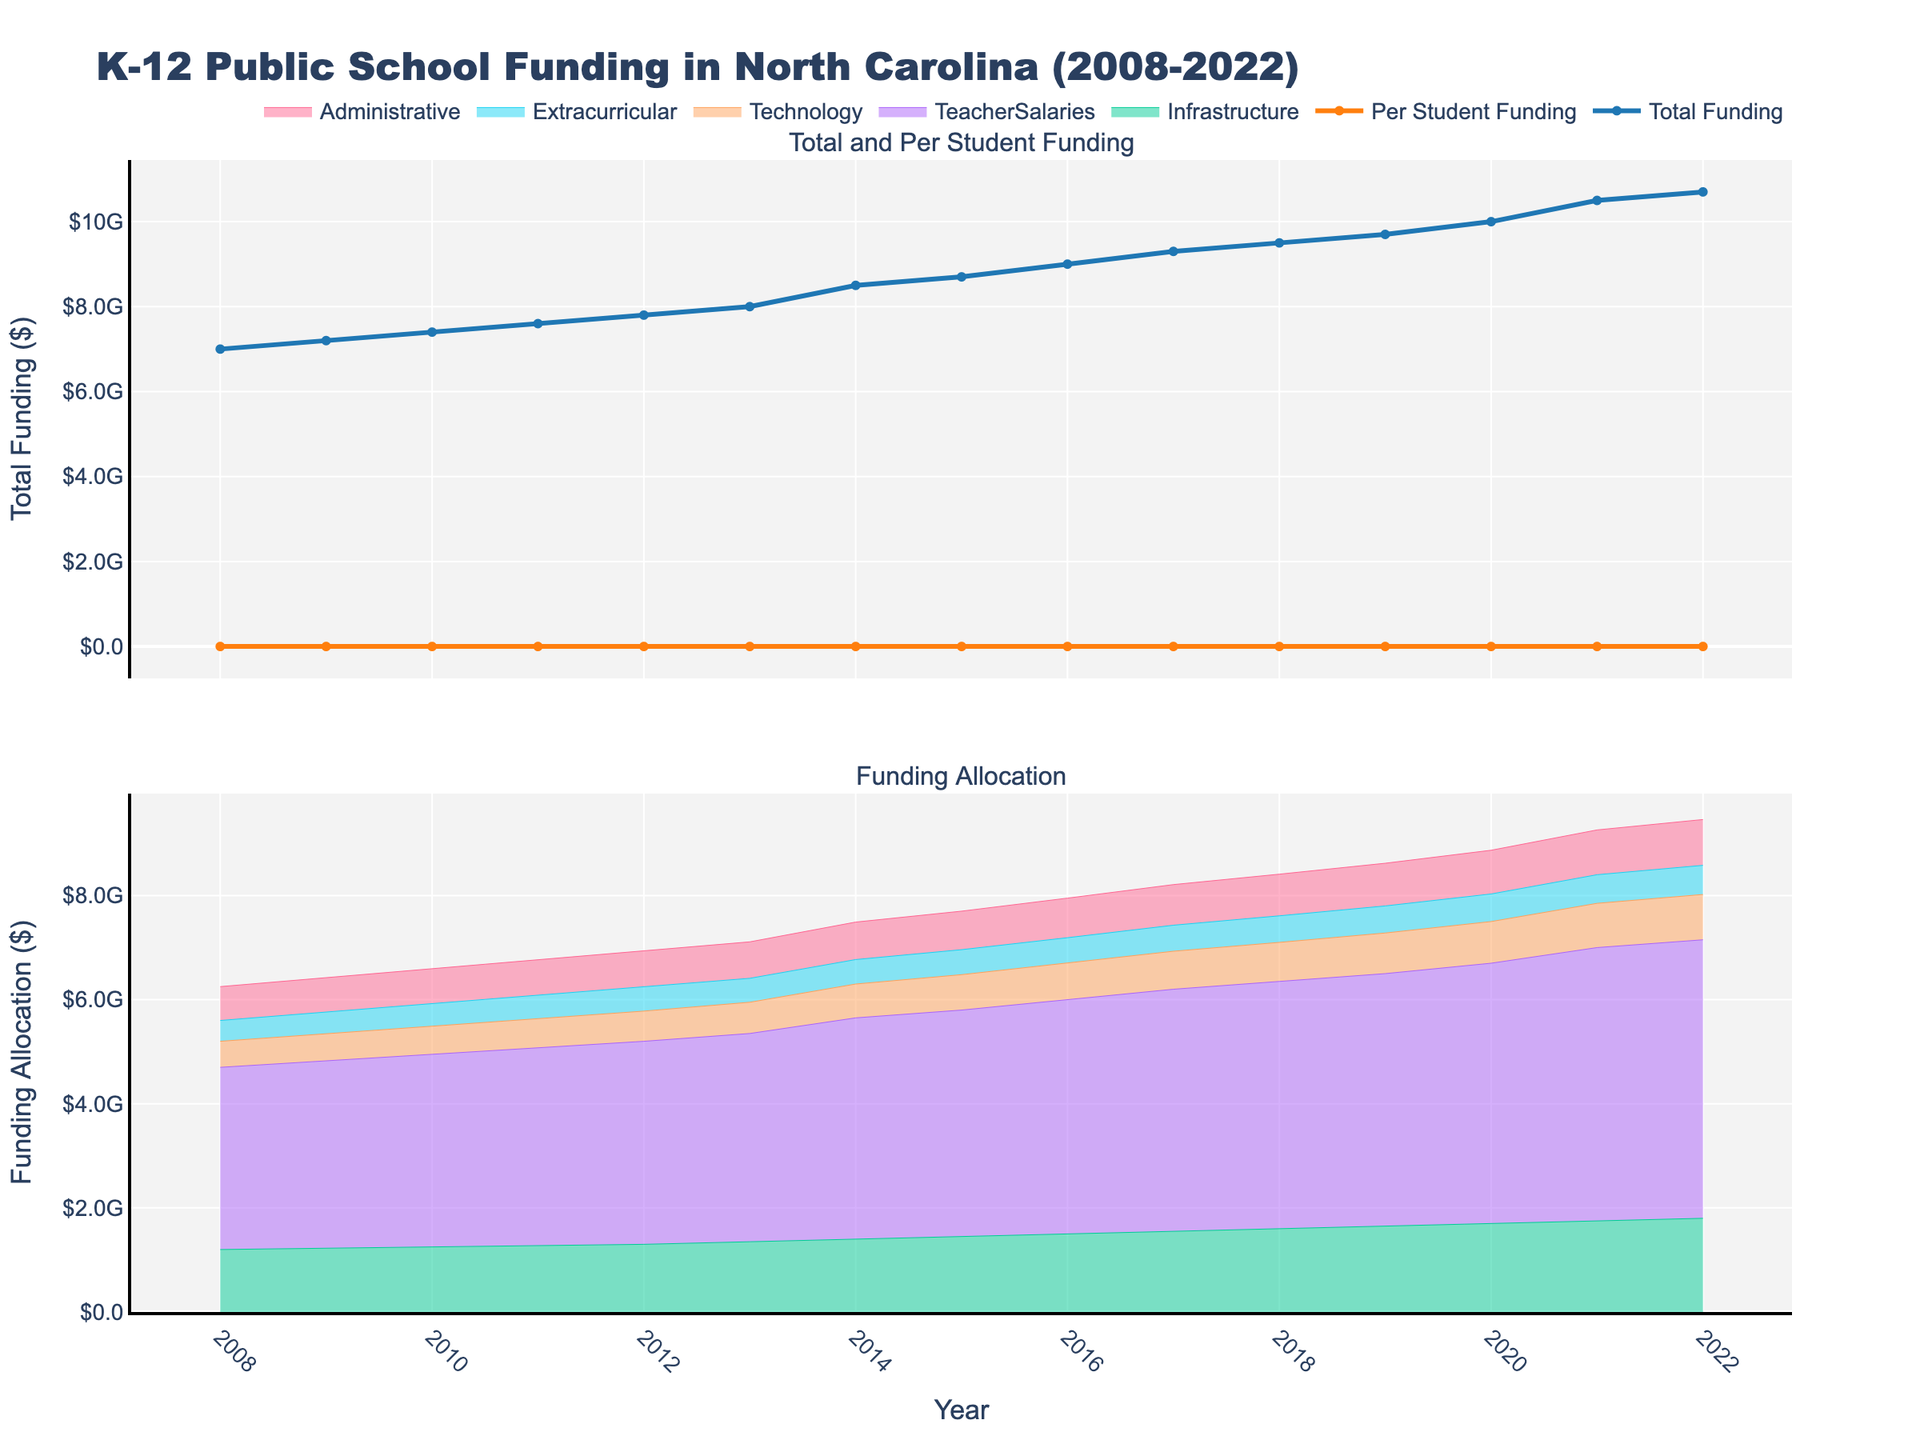what is the total funding in the year 2013? By looking at the "Total Funding" trend line, locate the value corresponding to the year 2013.
Answer: 8 billion dollars what year marked the highest per student funding? Observe the "Per Student Funding" trend line and identify the highest point on the graph, then check the corresponding year.
Answer: 2022 how did the allocation for teacher salaries change from 2015 to 2016? Compare the plotted values for "Teacher Salaries" in 2015 and 2016 by examining their relative heights on the graph.
Answer: Increased by 150 million dollars which funding category showed the least growth over the 15 years? Identify and compare the slopes or heights of the lines for each funding category from the graph. The category with the flattest curve has the least growth.
Answer: Administrative what was the difference between the total funding and the infrastructure funding in 2020? Subtract the "Infrastructure" funding value for 2020 from the "Total Funding" value for the same year from the plot.
Answer: 8.3 billion dollars how did total funding change between 2008 and 2022? Compare the "Total Funding" values at the starting year 2008 and the final year 2022 to determine the change.
Answer: Increased by 3.7 billion dollars which year saw the highest increase in technology funding? Identify the year where the slope of the "Technology" funding line is steepest, indicating the highest increase.
Answer: 2021 how are funding allocations distributed in 2022? Look at the height of each stacked segment for the various funding categories in 2022 to understand their distribution.
Answer: Infrastructure: 1.8 billion, Teacher Salaries: 5.35 billion, Technology: 870 million, Extracurricular: 560 million, Administrative: 880 million is the increase in per student funding proportionate to the total funding increase over the years? Compare the trend lines of "Per Student Funding" and "Total Funding" to see if they have similar patterns and slopes, indicating proportionality.
Answer: Yes what does the widening gap between total funding and per student funding indicate over time? Analyze how the difference between the "Total Funding" and "Per Student Funding" trend lines changes over time and infer the underlying factors, such as student enrollment figures.
Answer: Indicates increasing student enrollment 